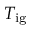<formula> <loc_0><loc_0><loc_500><loc_500>T _ { i g }</formula> 